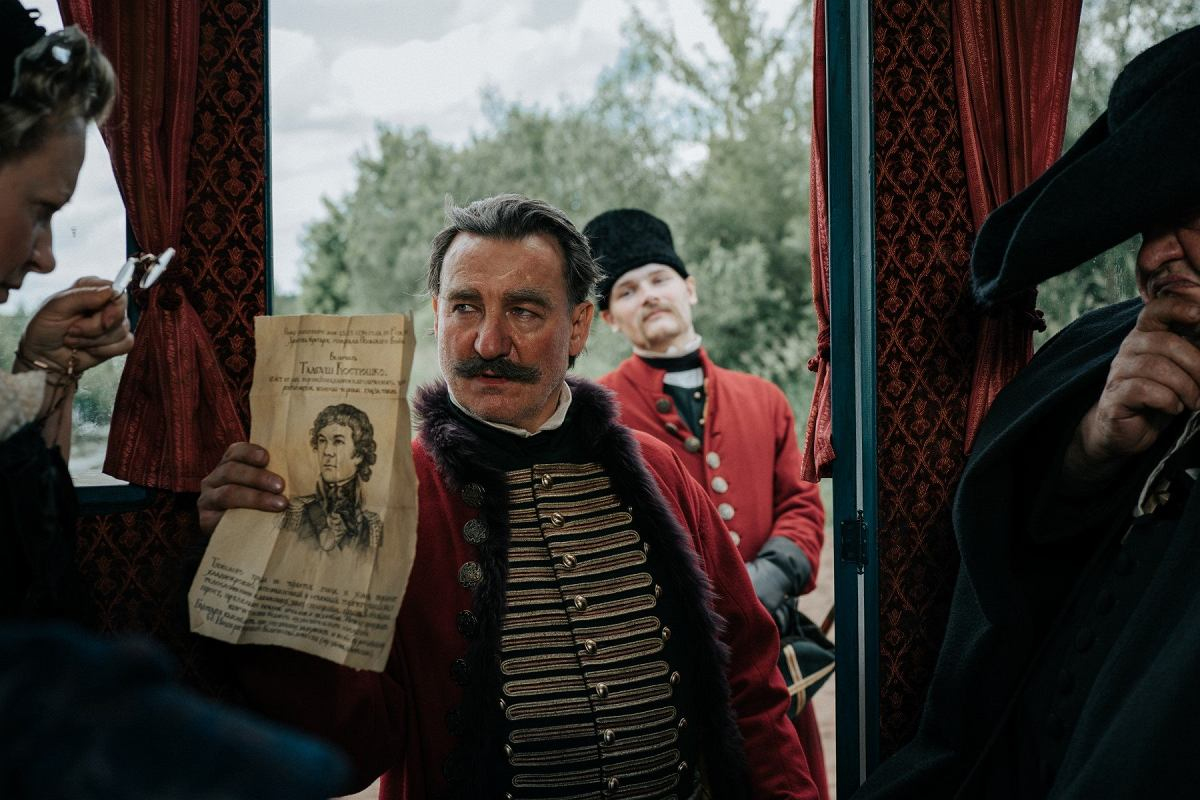Analyze the image in a comprehensive and detailed manner. In this historical scene, a central male character wearing a richly decorated military uniform, complete with gold epaulettes and a red sash across his chest, is the focal point. He is holding a paper that carries a portrait, possibly playing a significant role in the plot or theme of the scene. The attire and backdrop suggest a 19th-century European setting. In the background, additional characters in red military uniforms contribute to the ambiance, underscoring the scene's historical and possibly ceremonial context. The expression of the man and his focused gaze towards the viewer adds a dramatic flair to the image, hinting at the meaningful interaction of the depicted document in the storyline. 